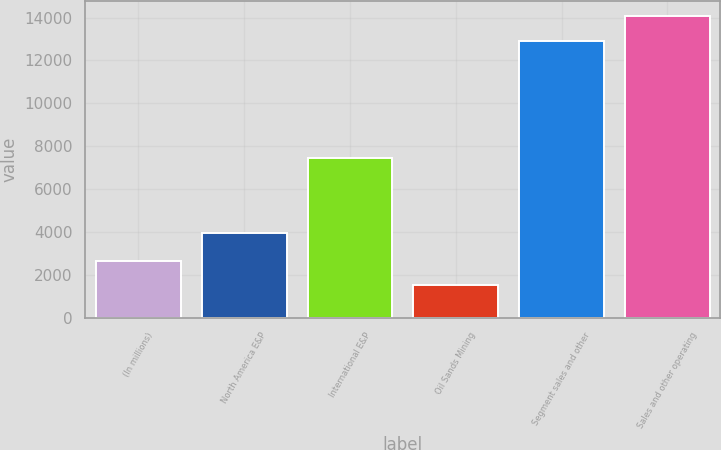Convert chart. <chart><loc_0><loc_0><loc_500><loc_500><bar_chart><fcel>(In millions)<fcel>North America E&P<fcel>International E&P<fcel>Oil Sands Mining<fcel>Segment sales and other<fcel>Sales and other operating<nl><fcel>2665.2<fcel>3944<fcel>7445<fcel>1521<fcel>12910<fcel>14054.2<nl></chart> 